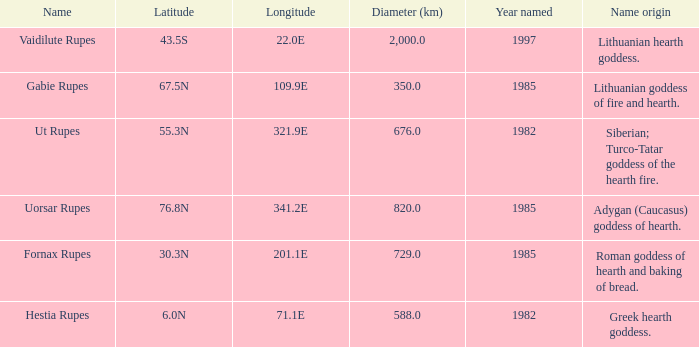What is the latitude of vaidilute rupes? 43.5S. 